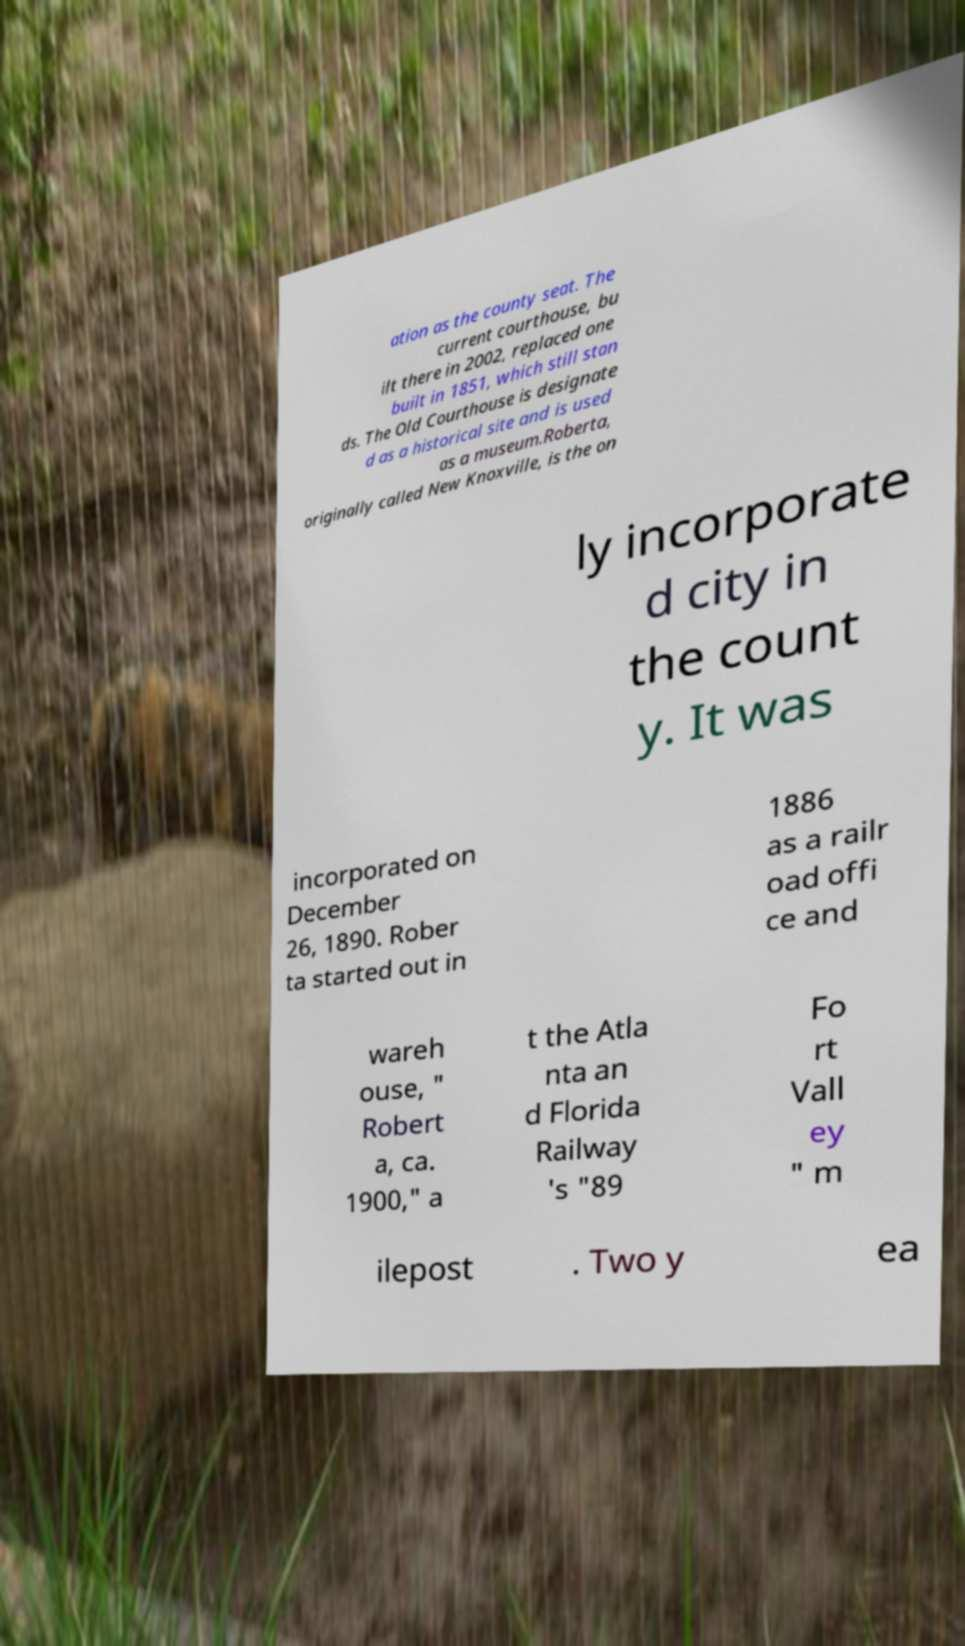What messages or text are displayed in this image? I need them in a readable, typed format. ation as the county seat. The current courthouse, bu ilt there in 2002, replaced one built in 1851, which still stan ds. The Old Courthouse is designate d as a historical site and is used as a museum.Roberta, originally called New Knoxville, is the on ly incorporate d city in the count y. It was incorporated on December 26, 1890. Rober ta started out in 1886 as a railr oad offi ce and wareh ouse, " Robert a, ca. 1900," a t the Atla nta an d Florida Railway 's "89 Fo rt Vall ey " m ilepost . Two y ea 